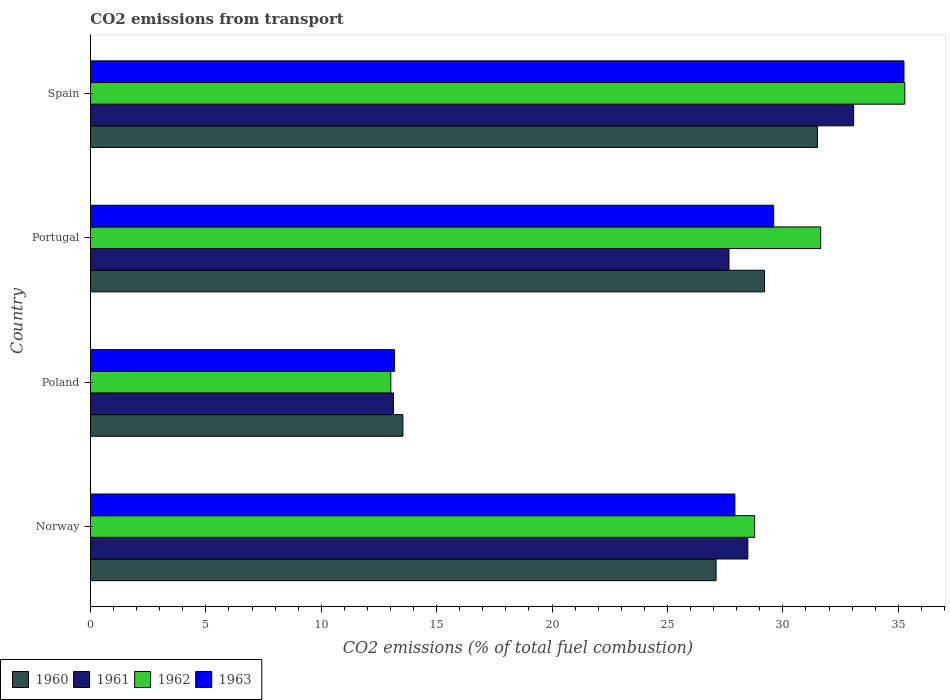How many different coloured bars are there?
Keep it short and to the point. 4. Are the number of bars per tick equal to the number of legend labels?
Provide a succinct answer. Yes. How many bars are there on the 2nd tick from the bottom?
Your answer should be very brief. 4. What is the label of the 4th group of bars from the top?
Give a very brief answer. Norway. In how many cases, is the number of bars for a given country not equal to the number of legend labels?
Keep it short and to the point. 0. What is the total CO2 emitted in 1960 in Spain?
Offer a very short reply. 31.5. Across all countries, what is the maximum total CO2 emitted in 1962?
Give a very brief answer. 35.28. Across all countries, what is the minimum total CO2 emitted in 1960?
Ensure brevity in your answer.  13.54. What is the total total CO2 emitted in 1960 in the graph?
Provide a short and direct response. 101.35. What is the difference between the total CO2 emitted in 1962 in Portugal and that in Spain?
Give a very brief answer. -3.64. What is the difference between the total CO2 emitted in 1960 in Poland and the total CO2 emitted in 1962 in Spain?
Ensure brevity in your answer.  -21.75. What is the average total CO2 emitted in 1962 per country?
Keep it short and to the point. 27.18. What is the difference between the total CO2 emitted in 1963 and total CO2 emitted in 1961 in Poland?
Offer a terse response. 0.05. In how many countries, is the total CO2 emitted in 1960 greater than 24 ?
Keep it short and to the point. 3. What is the ratio of the total CO2 emitted in 1961 in Poland to that in Portugal?
Offer a terse response. 0.47. Is the total CO2 emitted in 1963 in Poland less than that in Spain?
Make the answer very short. Yes. What is the difference between the highest and the second highest total CO2 emitted in 1962?
Your response must be concise. 3.64. What is the difference between the highest and the lowest total CO2 emitted in 1960?
Your answer should be very brief. 17.96. Is it the case that in every country, the sum of the total CO2 emitted in 1963 and total CO2 emitted in 1961 is greater than the sum of total CO2 emitted in 1960 and total CO2 emitted in 1962?
Your response must be concise. No. What does the 2nd bar from the top in Norway represents?
Offer a terse response. 1962. Are all the bars in the graph horizontal?
Your response must be concise. Yes. What is the difference between two consecutive major ticks on the X-axis?
Your answer should be very brief. 5. Are the values on the major ticks of X-axis written in scientific E-notation?
Your answer should be compact. No. Does the graph contain any zero values?
Give a very brief answer. No. Where does the legend appear in the graph?
Your response must be concise. Bottom left. How many legend labels are there?
Your answer should be compact. 4. What is the title of the graph?
Make the answer very short. CO2 emissions from transport. Does "1987" appear as one of the legend labels in the graph?
Keep it short and to the point. No. What is the label or title of the X-axis?
Make the answer very short. CO2 emissions (% of total fuel combustion). What is the CO2 emissions (% of total fuel combustion) in 1960 in Norway?
Make the answer very short. 27.11. What is the CO2 emissions (% of total fuel combustion) of 1961 in Norway?
Offer a very short reply. 28.48. What is the CO2 emissions (% of total fuel combustion) in 1962 in Norway?
Provide a succinct answer. 28.78. What is the CO2 emissions (% of total fuel combustion) of 1963 in Norway?
Offer a terse response. 27.92. What is the CO2 emissions (% of total fuel combustion) in 1960 in Poland?
Ensure brevity in your answer.  13.54. What is the CO2 emissions (% of total fuel combustion) of 1961 in Poland?
Make the answer very short. 13.13. What is the CO2 emissions (% of total fuel combustion) in 1962 in Poland?
Give a very brief answer. 13.01. What is the CO2 emissions (% of total fuel combustion) in 1963 in Poland?
Provide a succinct answer. 13.17. What is the CO2 emissions (% of total fuel combustion) in 1960 in Portugal?
Ensure brevity in your answer.  29.21. What is the CO2 emissions (% of total fuel combustion) of 1961 in Portugal?
Your answer should be compact. 27.67. What is the CO2 emissions (% of total fuel combustion) in 1962 in Portugal?
Your response must be concise. 31.64. What is the CO2 emissions (% of total fuel combustion) in 1963 in Portugal?
Ensure brevity in your answer.  29.6. What is the CO2 emissions (% of total fuel combustion) of 1960 in Spain?
Offer a very short reply. 31.5. What is the CO2 emissions (% of total fuel combustion) of 1961 in Spain?
Your response must be concise. 33.07. What is the CO2 emissions (% of total fuel combustion) in 1962 in Spain?
Make the answer very short. 35.28. What is the CO2 emissions (% of total fuel combustion) of 1963 in Spain?
Give a very brief answer. 35.25. Across all countries, what is the maximum CO2 emissions (% of total fuel combustion) of 1960?
Provide a succinct answer. 31.5. Across all countries, what is the maximum CO2 emissions (% of total fuel combustion) of 1961?
Provide a succinct answer. 33.07. Across all countries, what is the maximum CO2 emissions (% of total fuel combustion) in 1962?
Provide a succinct answer. 35.28. Across all countries, what is the maximum CO2 emissions (% of total fuel combustion) of 1963?
Give a very brief answer. 35.25. Across all countries, what is the minimum CO2 emissions (% of total fuel combustion) in 1960?
Your response must be concise. 13.54. Across all countries, what is the minimum CO2 emissions (% of total fuel combustion) of 1961?
Give a very brief answer. 13.13. Across all countries, what is the minimum CO2 emissions (% of total fuel combustion) in 1962?
Your answer should be very brief. 13.01. Across all countries, what is the minimum CO2 emissions (% of total fuel combustion) in 1963?
Offer a very short reply. 13.17. What is the total CO2 emissions (% of total fuel combustion) of 1960 in the graph?
Make the answer very short. 101.35. What is the total CO2 emissions (% of total fuel combustion) in 1961 in the graph?
Give a very brief answer. 102.34. What is the total CO2 emissions (% of total fuel combustion) in 1962 in the graph?
Your answer should be compact. 108.71. What is the total CO2 emissions (% of total fuel combustion) of 1963 in the graph?
Ensure brevity in your answer.  105.95. What is the difference between the CO2 emissions (% of total fuel combustion) in 1960 in Norway and that in Poland?
Your answer should be compact. 13.57. What is the difference between the CO2 emissions (% of total fuel combustion) in 1961 in Norway and that in Poland?
Provide a short and direct response. 15.36. What is the difference between the CO2 emissions (% of total fuel combustion) of 1962 in Norway and that in Poland?
Provide a short and direct response. 15.76. What is the difference between the CO2 emissions (% of total fuel combustion) of 1963 in Norway and that in Poland?
Provide a short and direct response. 14.75. What is the difference between the CO2 emissions (% of total fuel combustion) of 1960 in Norway and that in Portugal?
Make the answer very short. -2.1. What is the difference between the CO2 emissions (% of total fuel combustion) of 1961 in Norway and that in Portugal?
Keep it short and to the point. 0.82. What is the difference between the CO2 emissions (% of total fuel combustion) of 1962 in Norway and that in Portugal?
Keep it short and to the point. -2.86. What is the difference between the CO2 emissions (% of total fuel combustion) in 1963 in Norway and that in Portugal?
Ensure brevity in your answer.  -1.68. What is the difference between the CO2 emissions (% of total fuel combustion) of 1960 in Norway and that in Spain?
Your response must be concise. -4.39. What is the difference between the CO2 emissions (% of total fuel combustion) of 1961 in Norway and that in Spain?
Ensure brevity in your answer.  -4.58. What is the difference between the CO2 emissions (% of total fuel combustion) of 1962 in Norway and that in Spain?
Offer a very short reply. -6.51. What is the difference between the CO2 emissions (% of total fuel combustion) in 1963 in Norway and that in Spain?
Offer a very short reply. -7.33. What is the difference between the CO2 emissions (% of total fuel combustion) of 1960 in Poland and that in Portugal?
Offer a terse response. -15.67. What is the difference between the CO2 emissions (% of total fuel combustion) in 1961 in Poland and that in Portugal?
Keep it short and to the point. -14.54. What is the difference between the CO2 emissions (% of total fuel combustion) of 1962 in Poland and that in Portugal?
Your answer should be compact. -18.62. What is the difference between the CO2 emissions (% of total fuel combustion) of 1963 in Poland and that in Portugal?
Your response must be concise. -16.43. What is the difference between the CO2 emissions (% of total fuel combustion) of 1960 in Poland and that in Spain?
Provide a succinct answer. -17.96. What is the difference between the CO2 emissions (% of total fuel combustion) in 1961 in Poland and that in Spain?
Provide a succinct answer. -19.94. What is the difference between the CO2 emissions (% of total fuel combustion) of 1962 in Poland and that in Spain?
Provide a short and direct response. -22.27. What is the difference between the CO2 emissions (% of total fuel combustion) in 1963 in Poland and that in Spain?
Offer a very short reply. -22.07. What is the difference between the CO2 emissions (% of total fuel combustion) in 1960 in Portugal and that in Spain?
Ensure brevity in your answer.  -2.29. What is the difference between the CO2 emissions (% of total fuel combustion) of 1961 in Portugal and that in Spain?
Your response must be concise. -5.4. What is the difference between the CO2 emissions (% of total fuel combustion) of 1962 in Portugal and that in Spain?
Provide a succinct answer. -3.64. What is the difference between the CO2 emissions (% of total fuel combustion) of 1963 in Portugal and that in Spain?
Offer a very short reply. -5.65. What is the difference between the CO2 emissions (% of total fuel combustion) in 1960 in Norway and the CO2 emissions (% of total fuel combustion) in 1961 in Poland?
Make the answer very short. 13.98. What is the difference between the CO2 emissions (% of total fuel combustion) of 1960 in Norway and the CO2 emissions (% of total fuel combustion) of 1962 in Poland?
Ensure brevity in your answer.  14.09. What is the difference between the CO2 emissions (% of total fuel combustion) of 1960 in Norway and the CO2 emissions (% of total fuel combustion) of 1963 in Poland?
Your response must be concise. 13.93. What is the difference between the CO2 emissions (% of total fuel combustion) in 1961 in Norway and the CO2 emissions (% of total fuel combustion) in 1962 in Poland?
Keep it short and to the point. 15.47. What is the difference between the CO2 emissions (% of total fuel combustion) of 1961 in Norway and the CO2 emissions (% of total fuel combustion) of 1963 in Poland?
Your answer should be very brief. 15.31. What is the difference between the CO2 emissions (% of total fuel combustion) of 1962 in Norway and the CO2 emissions (% of total fuel combustion) of 1963 in Poland?
Your answer should be compact. 15.6. What is the difference between the CO2 emissions (% of total fuel combustion) of 1960 in Norway and the CO2 emissions (% of total fuel combustion) of 1961 in Portugal?
Your answer should be very brief. -0.56. What is the difference between the CO2 emissions (% of total fuel combustion) in 1960 in Norway and the CO2 emissions (% of total fuel combustion) in 1962 in Portugal?
Your response must be concise. -4.53. What is the difference between the CO2 emissions (% of total fuel combustion) in 1960 in Norway and the CO2 emissions (% of total fuel combustion) in 1963 in Portugal?
Offer a very short reply. -2.49. What is the difference between the CO2 emissions (% of total fuel combustion) in 1961 in Norway and the CO2 emissions (% of total fuel combustion) in 1962 in Portugal?
Your answer should be compact. -3.16. What is the difference between the CO2 emissions (% of total fuel combustion) of 1961 in Norway and the CO2 emissions (% of total fuel combustion) of 1963 in Portugal?
Ensure brevity in your answer.  -1.12. What is the difference between the CO2 emissions (% of total fuel combustion) of 1962 in Norway and the CO2 emissions (% of total fuel combustion) of 1963 in Portugal?
Provide a short and direct response. -0.82. What is the difference between the CO2 emissions (% of total fuel combustion) of 1960 in Norway and the CO2 emissions (% of total fuel combustion) of 1961 in Spain?
Make the answer very short. -5.96. What is the difference between the CO2 emissions (% of total fuel combustion) in 1960 in Norway and the CO2 emissions (% of total fuel combustion) in 1962 in Spain?
Make the answer very short. -8.18. What is the difference between the CO2 emissions (% of total fuel combustion) in 1960 in Norway and the CO2 emissions (% of total fuel combustion) in 1963 in Spain?
Your answer should be very brief. -8.14. What is the difference between the CO2 emissions (% of total fuel combustion) of 1961 in Norway and the CO2 emissions (% of total fuel combustion) of 1962 in Spain?
Offer a very short reply. -6.8. What is the difference between the CO2 emissions (% of total fuel combustion) in 1961 in Norway and the CO2 emissions (% of total fuel combustion) in 1963 in Spain?
Ensure brevity in your answer.  -6.77. What is the difference between the CO2 emissions (% of total fuel combustion) of 1962 in Norway and the CO2 emissions (% of total fuel combustion) of 1963 in Spain?
Give a very brief answer. -6.47. What is the difference between the CO2 emissions (% of total fuel combustion) in 1960 in Poland and the CO2 emissions (% of total fuel combustion) in 1961 in Portugal?
Provide a short and direct response. -14.13. What is the difference between the CO2 emissions (% of total fuel combustion) in 1960 in Poland and the CO2 emissions (% of total fuel combustion) in 1962 in Portugal?
Offer a very short reply. -18.1. What is the difference between the CO2 emissions (% of total fuel combustion) in 1960 in Poland and the CO2 emissions (% of total fuel combustion) in 1963 in Portugal?
Your answer should be compact. -16.06. What is the difference between the CO2 emissions (% of total fuel combustion) in 1961 in Poland and the CO2 emissions (% of total fuel combustion) in 1962 in Portugal?
Offer a terse response. -18.51. What is the difference between the CO2 emissions (% of total fuel combustion) in 1961 in Poland and the CO2 emissions (% of total fuel combustion) in 1963 in Portugal?
Make the answer very short. -16.47. What is the difference between the CO2 emissions (% of total fuel combustion) of 1962 in Poland and the CO2 emissions (% of total fuel combustion) of 1963 in Portugal?
Offer a terse response. -16.59. What is the difference between the CO2 emissions (% of total fuel combustion) of 1960 in Poland and the CO2 emissions (% of total fuel combustion) of 1961 in Spain?
Make the answer very short. -19.53. What is the difference between the CO2 emissions (% of total fuel combustion) in 1960 in Poland and the CO2 emissions (% of total fuel combustion) in 1962 in Spain?
Offer a terse response. -21.75. What is the difference between the CO2 emissions (% of total fuel combustion) in 1960 in Poland and the CO2 emissions (% of total fuel combustion) in 1963 in Spain?
Provide a short and direct response. -21.71. What is the difference between the CO2 emissions (% of total fuel combustion) of 1961 in Poland and the CO2 emissions (% of total fuel combustion) of 1962 in Spain?
Your answer should be very brief. -22.16. What is the difference between the CO2 emissions (% of total fuel combustion) of 1961 in Poland and the CO2 emissions (% of total fuel combustion) of 1963 in Spain?
Provide a short and direct response. -22.12. What is the difference between the CO2 emissions (% of total fuel combustion) in 1962 in Poland and the CO2 emissions (% of total fuel combustion) in 1963 in Spain?
Keep it short and to the point. -22.23. What is the difference between the CO2 emissions (% of total fuel combustion) in 1960 in Portugal and the CO2 emissions (% of total fuel combustion) in 1961 in Spain?
Provide a short and direct response. -3.86. What is the difference between the CO2 emissions (% of total fuel combustion) in 1960 in Portugal and the CO2 emissions (% of total fuel combustion) in 1962 in Spain?
Ensure brevity in your answer.  -6.08. What is the difference between the CO2 emissions (% of total fuel combustion) of 1960 in Portugal and the CO2 emissions (% of total fuel combustion) of 1963 in Spain?
Your answer should be compact. -6.04. What is the difference between the CO2 emissions (% of total fuel combustion) of 1961 in Portugal and the CO2 emissions (% of total fuel combustion) of 1962 in Spain?
Provide a succinct answer. -7.62. What is the difference between the CO2 emissions (% of total fuel combustion) of 1961 in Portugal and the CO2 emissions (% of total fuel combustion) of 1963 in Spain?
Ensure brevity in your answer.  -7.58. What is the difference between the CO2 emissions (% of total fuel combustion) of 1962 in Portugal and the CO2 emissions (% of total fuel combustion) of 1963 in Spain?
Keep it short and to the point. -3.61. What is the average CO2 emissions (% of total fuel combustion) of 1960 per country?
Provide a short and direct response. 25.34. What is the average CO2 emissions (% of total fuel combustion) in 1961 per country?
Your answer should be compact. 25.59. What is the average CO2 emissions (% of total fuel combustion) in 1962 per country?
Make the answer very short. 27.18. What is the average CO2 emissions (% of total fuel combustion) of 1963 per country?
Offer a terse response. 26.49. What is the difference between the CO2 emissions (% of total fuel combustion) in 1960 and CO2 emissions (% of total fuel combustion) in 1961 in Norway?
Ensure brevity in your answer.  -1.38. What is the difference between the CO2 emissions (% of total fuel combustion) of 1960 and CO2 emissions (% of total fuel combustion) of 1962 in Norway?
Make the answer very short. -1.67. What is the difference between the CO2 emissions (% of total fuel combustion) of 1960 and CO2 emissions (% of total fuel combustion) of 1963 in Norway?
Offer a terse response. -0.82. What is the difference between the CO2 emissions (% of total fuel combustion) of 1961 and CO2 emissions (% of total fuel combustion) of 1962 in Norway?
Offer a very short reply. -0.29. What is the difference between the CO2 emissions (% of total fuel combustion) of 1961 and CO2 emissions (% of total fuel combustion) of 1963 in Norway?
Your response must be concise. 0.56. What is the difference between the CO2 emissions (% of total fuel combustion) of 1962 and CO2 emissions (% of total fuel combustion) of 1963 in Norway?
Provide a succinct answer. 0.85. What is the difference between the CO2 emissions (% of total fuel combustion) of 1960 and CO2 emissions (% of total fuel combustion) of 1961 in Poland?
Make the answer very short. 0.41. What is the difference between the CO2 emissions (% of total fuel combustion) of 1960 and CO2 emissions (% of total fuel combustion) of 1962 in Poland?
Make the answer very short. 0.52. What is the difference between the CO2 emissions (% of total fuel combustion) of 1960 and CO2 emissions (% of total fuel combustion) of 1963 in Poland?
Offer a very short reply. 0.36. What is the difference between the CO2 emissions (% of total fuel combustion) of 1961 and CO2 emissions (% of total fuel combustion) of 1962 in Poland?
Ensure brevity in your answer.  0.11. What is the difference between the CO2 emissions (% of total fuel combustion) in 1961 and CO2 emissions (% of total fuel combustion) in 1963 in Poland?
Your answer should be very brief. -0.05. What is the difference between the CO2 emissions (% of total fuel combustion) in 1962 and CO2 emissions (% of total fuel combustion) in 1963 in Poland?
Give a very brief answer. -0.16. What is the difference between the CO2 emissions (% of total fuel combustion) of 1960 and CO2 emissions (% of total fuel combustion) of 1961 in Portugal?
Make the answer very short. 1.54. What is the difference between the CO2 emissions (% of total fuel combustion) in 1960 and CO2 emissions (% of total fuel combustion) in 1962 in Portugal?
Give a very brief answer. -2.43. What is the difference between the CO2 emissions (% of total fuel combustion) in 1960 and CO2 emissions (% of total fuel combustion) in 1963 in Portugal?
Provide a short and direct response. -0.39. What is the difference between the CO2 emissions (% of total fuel combustion) of 1961 and CO2 emissions (% of total fuel combustion) of 1962 in Portugal?
Offer a very short reply. -3.97. What is the difference between the CO2 emissions (% of total fuel combustion) in 1961 and CO2 emissions (% of total fuel combustion) in 1963 in Portugal?
Offer a very short reply. -1.94. What is the difference between the CO2 emissions (% of total fuel combustion) of 1962 and CO2 emissions (% of total fuel combustion) of 1963 in Portugal?
Ensure brevity in your answer.  2.04. What is the difference between the CO2 emissions (% of total fuel combustion) in 1960 and CO2 emissions (% of total fuel combustion) in 1961 in Spain?
Your response must be concise. -1.57. What is the difference between the CO2 emissions (% of total fuel combustion) in 1960 and CO2 emissions (% of total fuel combustion) in 1962 in Spain?
Your answer should be compact. -3.78. What is the difference between the CO2 emissions (% of total fuel combustion) in 1960 and CO2 emissions (% of total fuel combustion) in 1963 in Spain?
Offer a very short reply. -3.75. What is the difference between the CO2 emissions (% of total fuel combustion) of 1961 and CO2 emissions (% of total fuel combustion) of 1962 in Spain?
Your answer should be very brief. -2.22. What is the difference between the CO2 emissions (% of total fuel combustion) in 1961 and CO2 emissions (% of total fuel combustion) in 1963 in Spain?
Your response must be concise. -2.18. What is the difference between the CO2 emissions (% of total fuel combustion) in 1962 and CO2 emissions (% of total fuel combustion) in 1963 in Spain?
Offer a very short reply. 0.04. What is the ratio of the CO2 emissions (% of total fuel combustion) in 1960 in Norway to that in Poland?
Offer a terse response. 2. What is the ratio of the CO2 emissions (% of total fuel combustion) in 1961 in Norway to that in Poland?
Give a very brief answer. 2.17. What is the ratio of the CO2 emissions (% of total fuel combustion) in 1962 in Norway to that in Poland?
Your response must be concise. 2.21. What is the ratio of the CO2 emissions (% of total fuel combustion) of 1963 in Norway to that in Poland?
Provide a short and direct response. 2.12. What is the ratio of the CO2 emissions (% of total fuel combustion) of 1960 in Norway to that in Portugal?
Keep it short and to the point. 0.93. What is the ratio of the CO2 emissions (% of total fuel combustion) in 1961 in Norway to that in Portugal?
Keep it short and to the point. 1.03. What is the ratio of the CO2 emissions (% of total fuel combustion) of 1962 in Norway to that in Portugal?
Give a very brief answer. 0.91. What is the ratio of the CO2 emissions (% of total fuel combustion) of 1963 in Norway to that in Portugal?
Your answer should be compact. 0.94. What is the ratio of the CO2 emissions (% of total fuel combustion) of 1960 in Norway to that in Spain?
Make the answer very short. 0.86. What is the ratio of the CO2 emissions (% of total fuel combustion) in 1961 in Norway to that in Spain?
Provide a short and direct response. 0.86. What is the ratio of the CO2 emissions (% of total fuel combustion) in 1962 in Norway to that in Spain?
Your response must be concise. 0.82. What is the ratio of the CO2 emissions (% of total fuel combustion) of 1963 in Norway to that in Spain?
Offer a very short reply. 0.79. What is the ratio of the CO2 emissions (% of total fuel combustion) of 1960 in Poland to that in Portugal?
Ensure brevity in your answer.  0.46. What is the ratio of the CO2 emissions (% of total fuel combustion) of 1961 in Poland to that in Portugal?
Give a very brief answer. 0.47. What is the ratio of the CO2 emissions (% of total fuel combustion) in 1962 in Poland to that in Portugal?
Provide a succinct answer. 0.41. What is the ratio of the CO2 emissions (% of total fuel combustion) of 1963 in Poland to that in Portugal?
Your answer should be compact. 0.45. What is the ratio of the CO2 emissions (% of total fuel combustion) in 1960 in Poland to that in Spain?
Your response must be concise. 0.43. What is the ratio of the CO2 emissions (% of total fuel combustion) in 1961 in Poland to that in Spain?
Keep it short and to the point. 0.4. What is the ratio of the CO2 emissions (% of total fuel combustion) in 1962 in Poland to that in Spain?
Your answer should be compact. 0.37. What is the ratio of the CO2 emissions (% of total fuel combustion) of 1963 in Poland to that in Spain?
Offer a terse response. 0.37. What is the ratio of the CO2 emissions (% of total fuel combustion) in 1960 in Portugal to that in Spain?
Offer a very short reply. 0.93. What is the ratio of the CO2 emissions (% of total fuel combustion) in 1961 in Portugal to that in Spain?
Ensure brevity in your answer.  0.84. What is the ratio of the CO2 emissions (% of total fuel combustion) in 1962 in Portugal to that in Spain?
Your answer should be very brief. 0.9. What is the ratio of the CO2 emissions (% of total fuel combustion) of 1963 in Portugal to that in Spain?
Ensure brevity in your answer.  0.84. What is the difference between the highest and the second highest CO2 emissions (% of total fuel combustion) of 1960?
Provide a succinct answer. 2.29. What is the difference between the highest and the second highest CO2 emissions (% of total fuel combustion) of 1961?
Make the answer very short. 4.58. What is the difference between the highest and the second highest CO2 emissions (% of total fuel combustion) of 1962?
Provide a succinct answer. 3.64. What is the difference between the highest and the second highest CO2 emissions (% of total fuel combustion) of 1963?
Provide a short and direct response. 5.65. What is the difference between the highest and the lowest CO2 emissions (% of total fuel combustion) of 1960?
Give a very brief answer. 17.96. What is the difference between the highest and the lowest CO2 emissions (% of total fuel combustion) of 1961?
Your answer should be very brief. 19.94. What is the difference between the highest and the lowest CO2 emissions (% of total fuel combustion) in 1962?
Provide a short and direct response. 22.27. What is the difference between the highest and the lowest CO2 emissions (% of total fuel combustion) in 1963?
Provide a succinct answer. 22.07. 